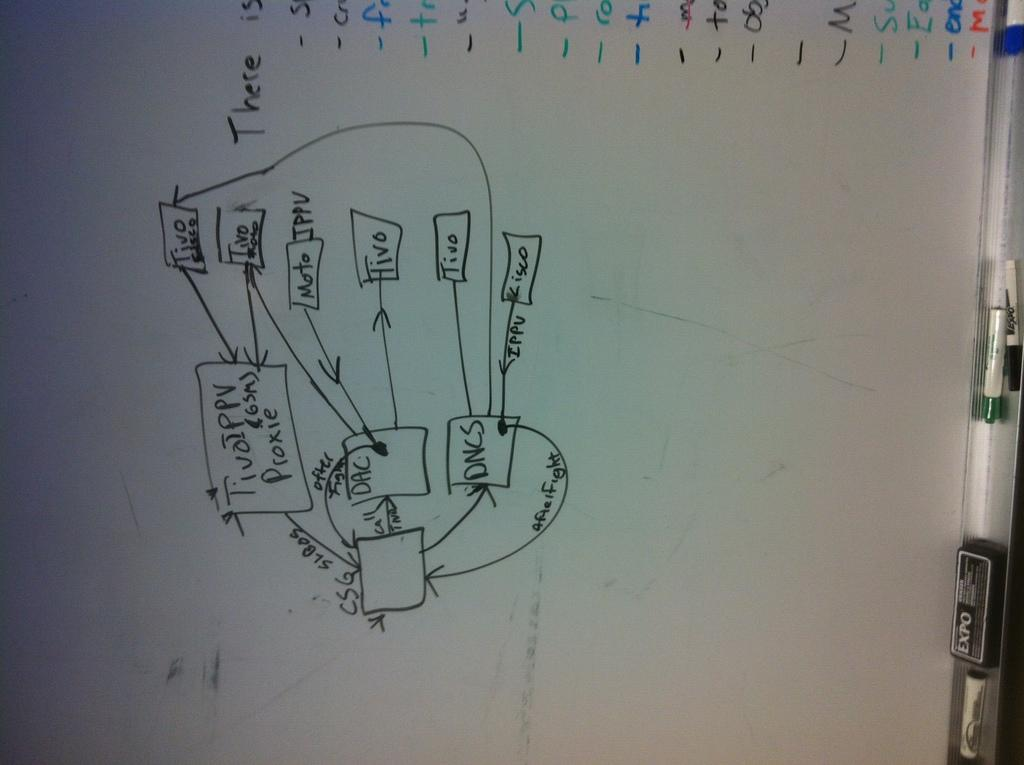Provide a one-sentence caption for the provided image. A flow Chart diagram on a white board with squares labeled DAC and DNCS. 